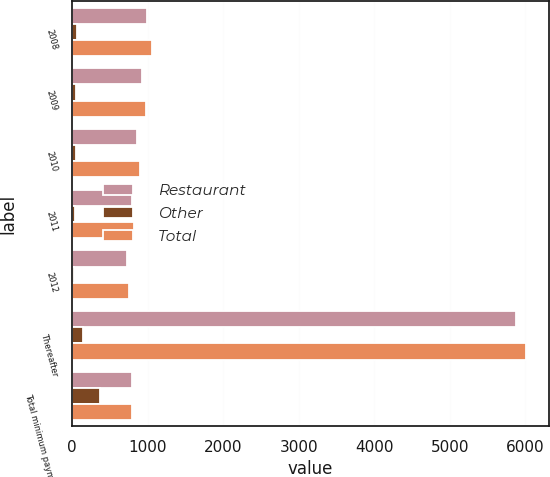<chart> <loc_0><loc_0><loc_500><loc_500><stacked_bar_chart><ecel><fcel>2008<fcel>2009<fcel>2010<fcel>2011<fcel>2012<fcel>Thereafter<fcel>Total minimum payments<nl><fcel>Restaurant<fcel>989.7<fcel>918.2<fcel>853.9<fcel>786.8<fcel>729.6<fcel>5869.5<fcel>786.8<nl><fcel>Other<fcel>64.1<fcel>55.4<fcel>44.6<fcel>35.2<fcel>27.7<fcel>139.1<fcel>366.1<nl><fcel>Total<fcel>1053.8<fcel>973.6<fcel>898.5<fcel>822<fcel>757.3<fcel>6008.6<fcel>786.8<nl></chart> 